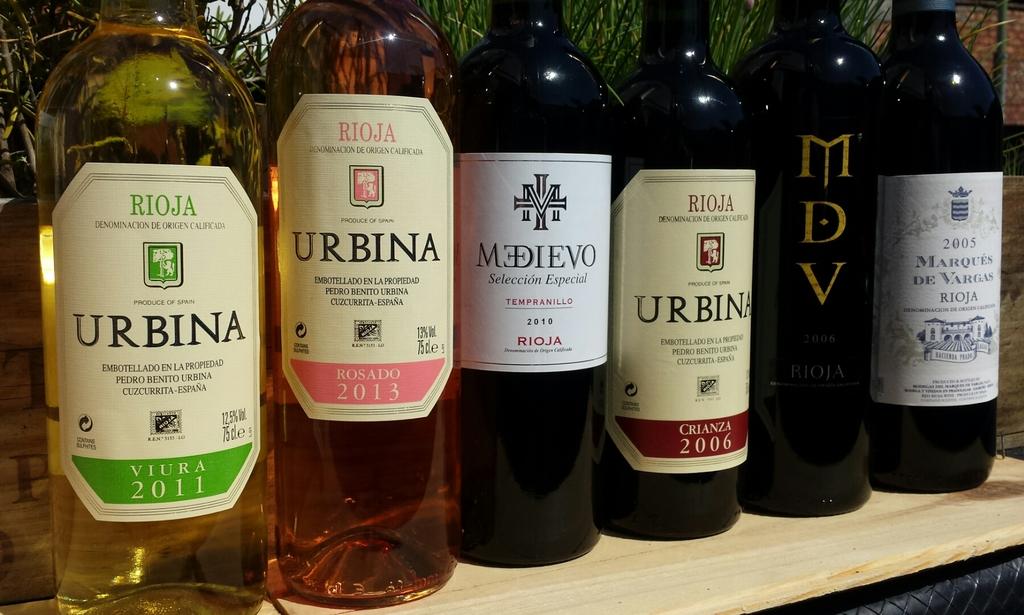What brand are the two wine bottles on the left?
Make the answer very short. Urbina. 